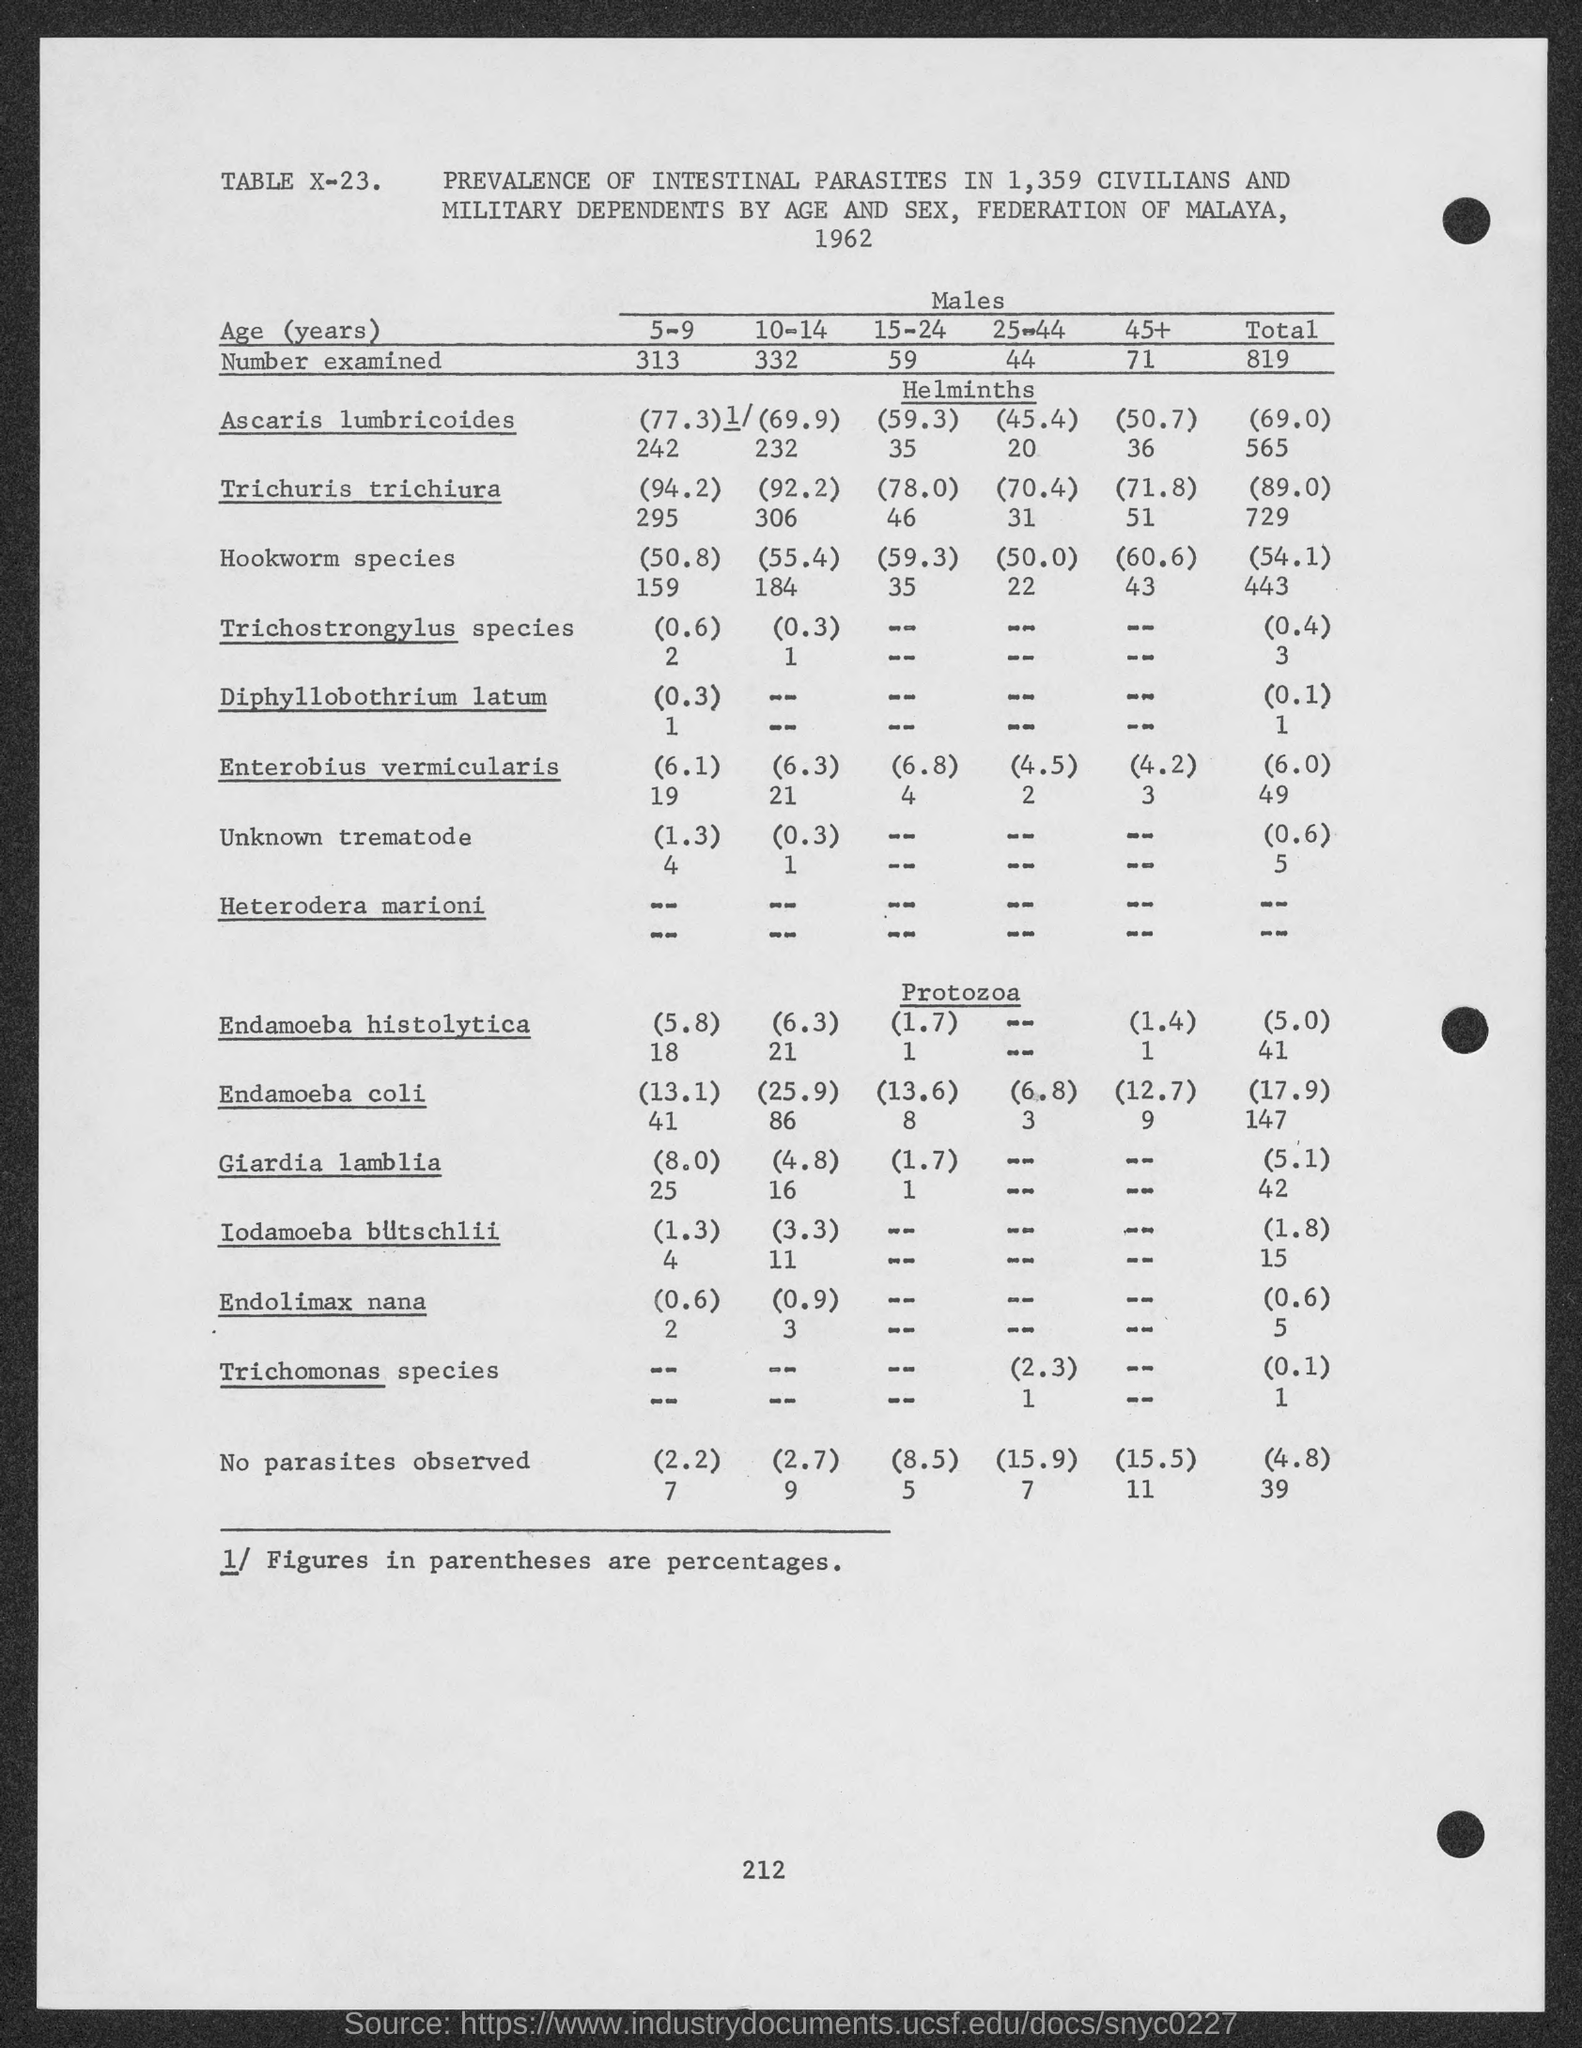Which year was the study conducted?
Make the answer very short. 1962. How many males where examined totally?
Your answer should be compact. 819. Ascaris lumbricoides comes under which heading?
Ensure brevity in your answer.  Helminths. Giardia lamblia comes under which heading ?
Give a very brief answer. Protozoa. What is the table number given in the top of the table?
Your response must be concise. X-23. What is the percentage of hookworm species present in total?
Ensure brevity in your answer.  54.1. 